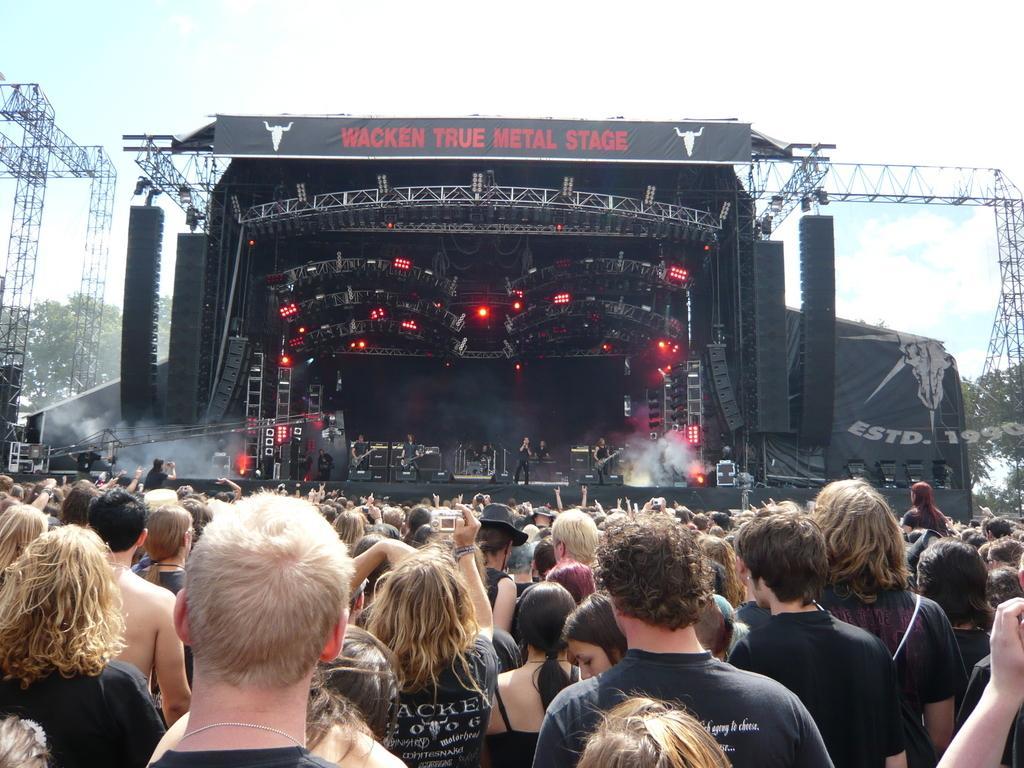How would you summarize this image in a sentence or two? In the image it looks like some concert, the stage is decorated with red lights and black objects and in front of the stage there is a huge crowd and there is some text written on the black background and kept above the concert stage. 